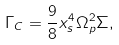<formula> <loc_0><loc_0><loc_500><loc_500>\Gamma _ { C } = \frac { 9 } { 8 } x _ { s } ^ { 4 } \Omega _ { p } ^ { 2 } \Sigma ,</formula> 